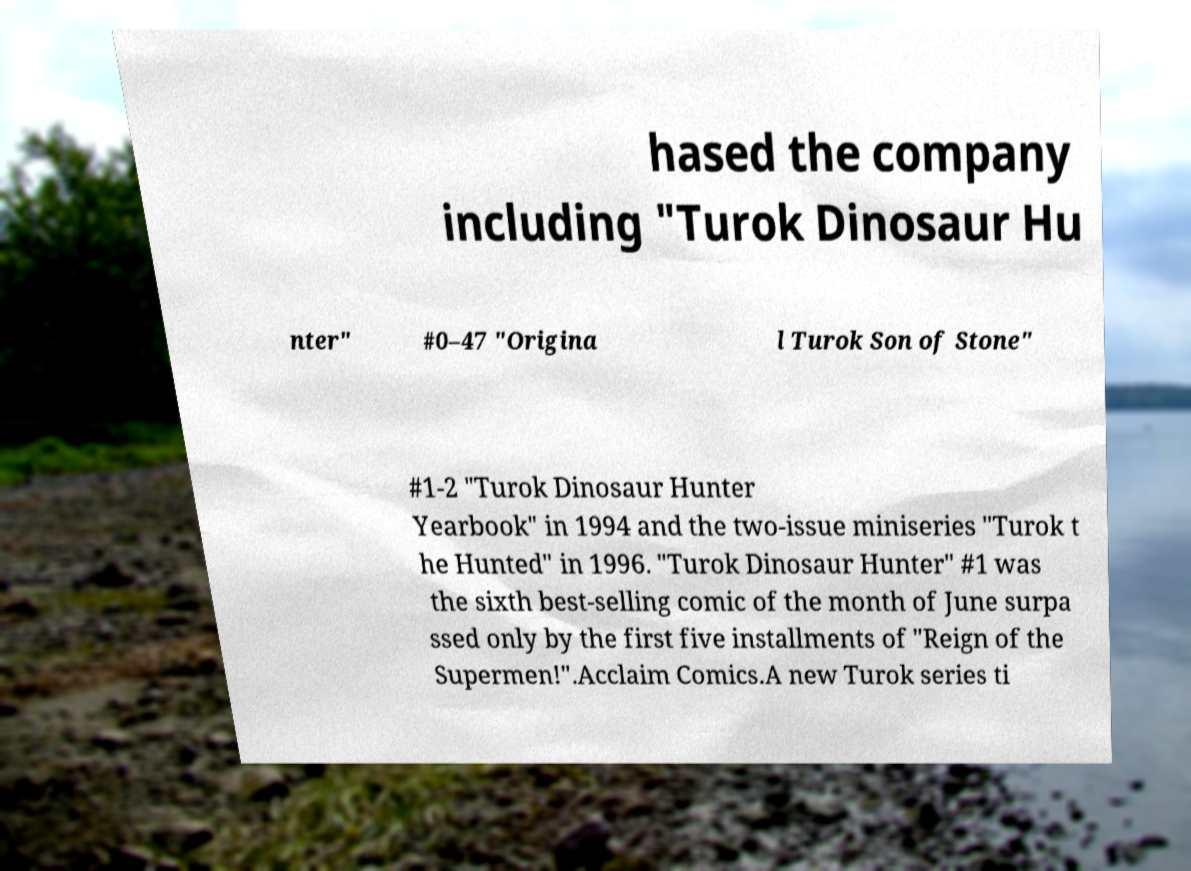I need the written content from this picture converted into text. Can you do that? hased the company including "Turok Dinosaur Hu nter" #0–47 "Origina l Turok Son of Stone" #1-2 "Turok Dinosaur Hunter Yearbook" in 1994 and the two-issue miniseries "Turok t he Hunted" in 1996. "Turok Dinosaur Hunter" #1 was the sixth best-selling comic of the month of June surpa ssed only by the first five installments of "Reign of the Supermen!".Acclaim Comics.A new Turok series ti 